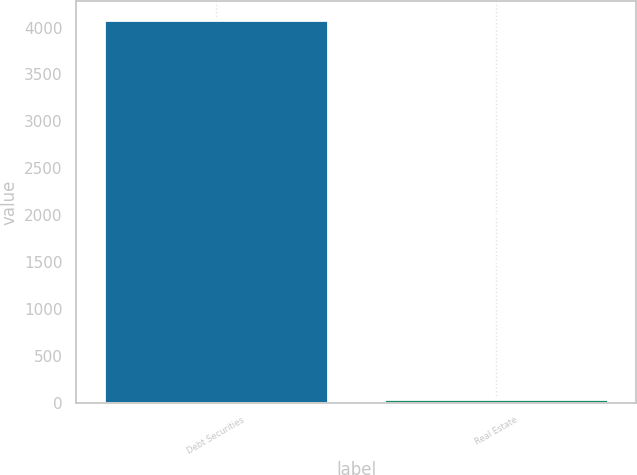Convert chart to OTSL. <chart><loc_0><loc_0><loc_500><loc_500><bar_chart><fcel>Debt Securities<fcel>Real Estate<nl><fcel>4076<fcel>36<nl></chart> 